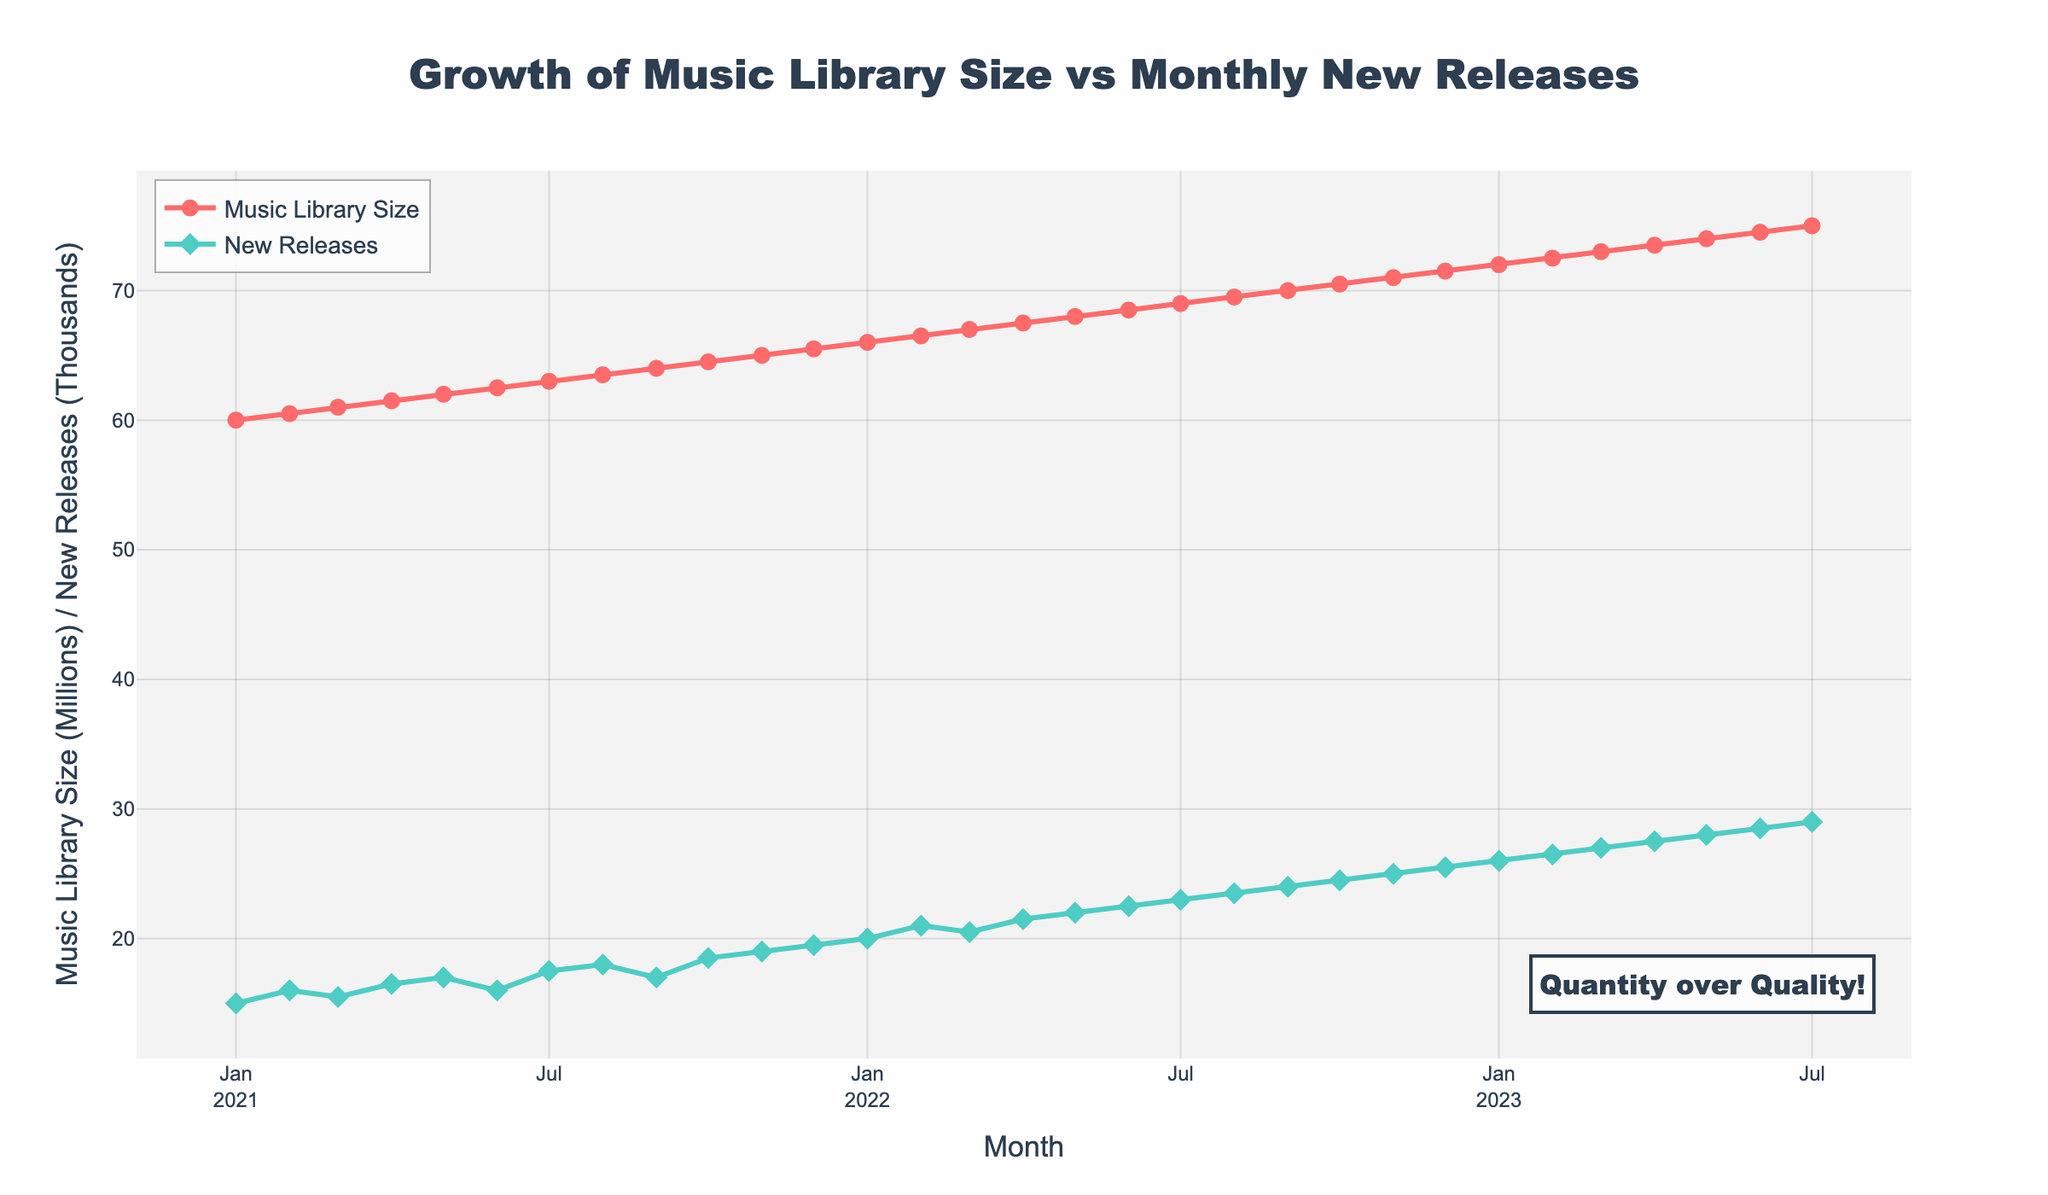what is the title of the figure? The title is located at the top of the figure and is centered. It typically summarizes the main topic or insight of the chart.
Answer: Growth of Music Library Size vs Monthly New Releases What is the color of the line representing the Music Library Size? The color of the line for the Music Library Size is distinguished and described in the legend of the figure. The line is in a distinct red hue.
Answer: Red How many new releases were there in January 2022? To find the new releases for January 2022, locate the corresponding month on the x-axis and read the y-value where the New Releases line (green color) intersects it.
Answer: 20,000 What month showed a peak in the number of new releases throughout the two years? To find the peak, look for the highest point on the New Releases (green) line and note the corresponding month on the x-axis.
Answer: July 2023 What was the size of the music library in July 2022? To find this value, locate July 2022 on the x-axis and read the y-value where the Music Library Size (red) line intersects it.
Answer: 69,000,000 Which month had the highest difference between New Releases and Music Library Size? This requires finding the month where the vertical distance between the red and green lines (Music Library Size and New Releases) is the maximum. Calculate the absolute difference for each month and compare.
Answer: July 2023 How did the New Releases trend from January 2021 to July 2023? By observing the green line from January 2021 to July 2023, we can note the overall increasing or decreasing trend. The line climbs steadily showing a consistent increase over time.
Answer: Increasing Compare the number of new releases between January 2021 and July 2023. How did it change? To compare, locate January 2021 and July 2023 on the x-axis and read the y-values of the New Releases line at those points. Subtract the former value from the latter.
Answer: Increase of 14,000 What is the annotation added to the graph and why might it be relevant? An annotation near the bottom-right corner of the graph reads "Quantity over Quality!" This annotation might be emphasizing the company's focus on increasing the volume of music content in the library.
Answer: Quantity over Quality! How does the growth rate of the Music Library Size compare to the growth rate of New Releases? Compare the slopes of the red and green lines respectively over the same period. Both lines slope upwards, but the New Releases line (green) has a steeper slope indicating a more rapid growth rate for new releases compared to music library size.
Answer: New Releases grew faster 